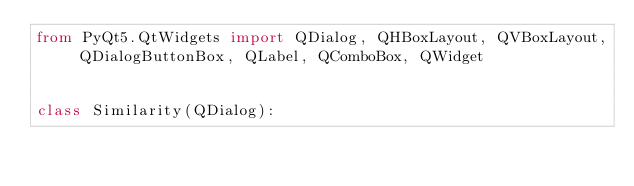<code> <loc_0><loc_0><loc_500><loc_500><_Python_>from PyQt5.QtWidgets import QDialog, QHBoxLayout, QVBoxLayout, QDialogButtonBox, QLabel, QComboBox, QWidget


class Similarity(QDialog):
</code> 